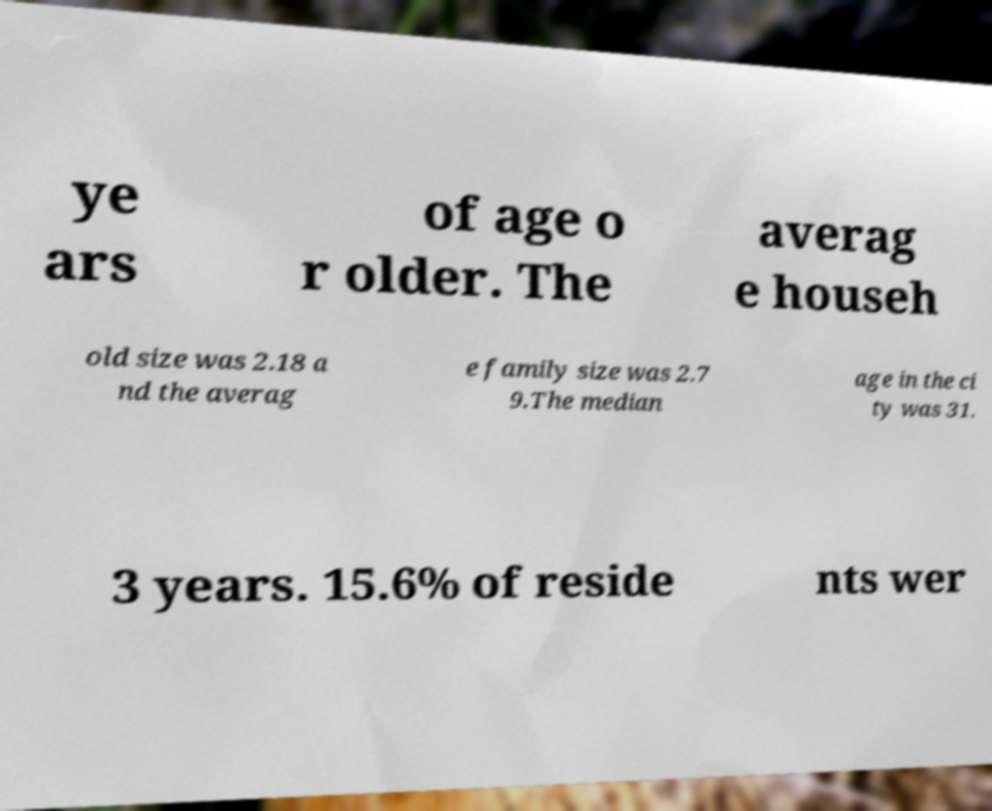Could you extract and type out the text from this image? ye ars of age o r older. The averag e househ old size was 2.18 a nd the averag e family size was 2.7 9.The median age in the ci ty was 31. 3 years. 15.6% of reside nts wer 